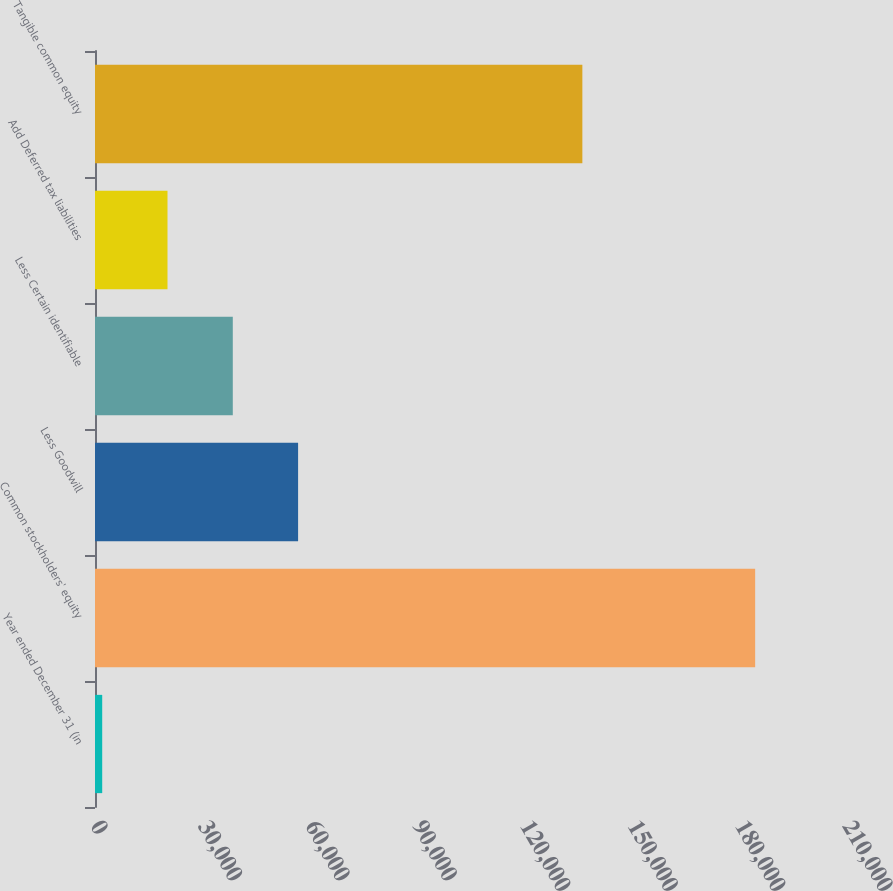<chart> <loc_0><loc_0><loc_500><loc_500><bar_chart><fcel>Year ended December 31 (in<fcel>Common stockholders' equity<fcel>Less Goodwill<fcel>Less Certain identifiable<fcel>Add Deferred tax liabilities<fcel>Tangible common equity<nl><fcel>2012<fcel>184352<fcel>56714<fcel>38480<fcel>20246<fcel>136097<nl></chart> 